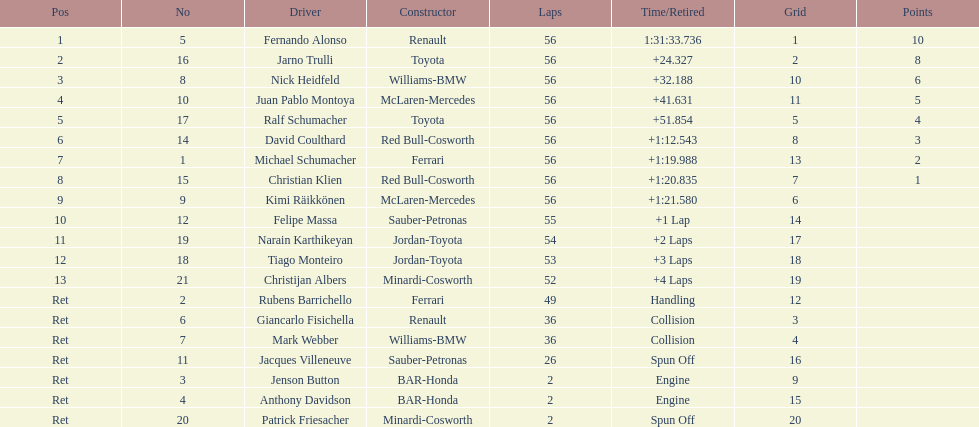How many germans finished in the top five? 2. 